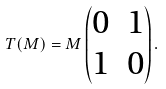<formula> <loc_0><loc_0><loc_500><loc_500>T ( M ) = M \begin{pmatrix} 0 & 1 \\ 1 & 0 \\ \end{pmatrix} .</formula> 